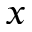Convert formula to latex. <formula><loc_0><loc_0><loc_500><loc_500>x</formula> 